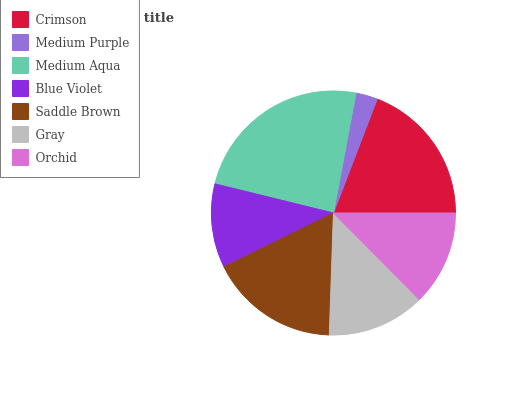Is Medium Purple the minimum?
Answer yes or no. Yes. Is Medium Aqua the maximum?
Answer yes or no. Yes. Is Medium Aqua the minimum?
Answer yes or no. No. Is Medium Purple the maximum?
Answer yes or no. No. Is Medium Aqua greater than Medium Purple?
Answer yes or no. Yes. Is Medium Purple less than Medium Aqua?
Answer yes or no. Yes. Is Medium Purple greater than Medium Aqua?
Answer yes or no. No. Is Medium Aqua less than Medium Purple?
Answer yes or no. No. Is Gray the high median?
Answer yes or no. Yes. Is Gray the low median?
Answer yes or no. Yes. Is Medium Aqua the high median?
Answer yes or no. No. Is Blue Violet the low median?
Answer yes or no. No. 